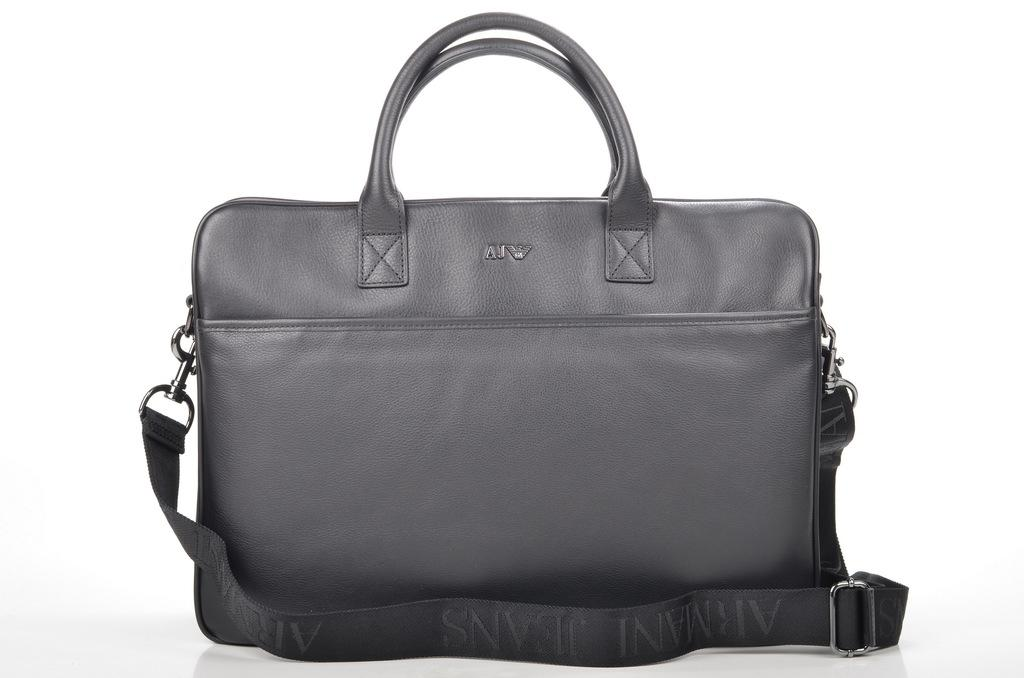What object is present in the image that is black in color? There is a black bag in the image. What is the color of the background in the image? The background of the image is white in color. What route is the bag taking in the image? The image does not depict a route or any movement of the bag. What religion is associated with the black bag in the image? The image does not provide any information about the religion associated with the black bag. 